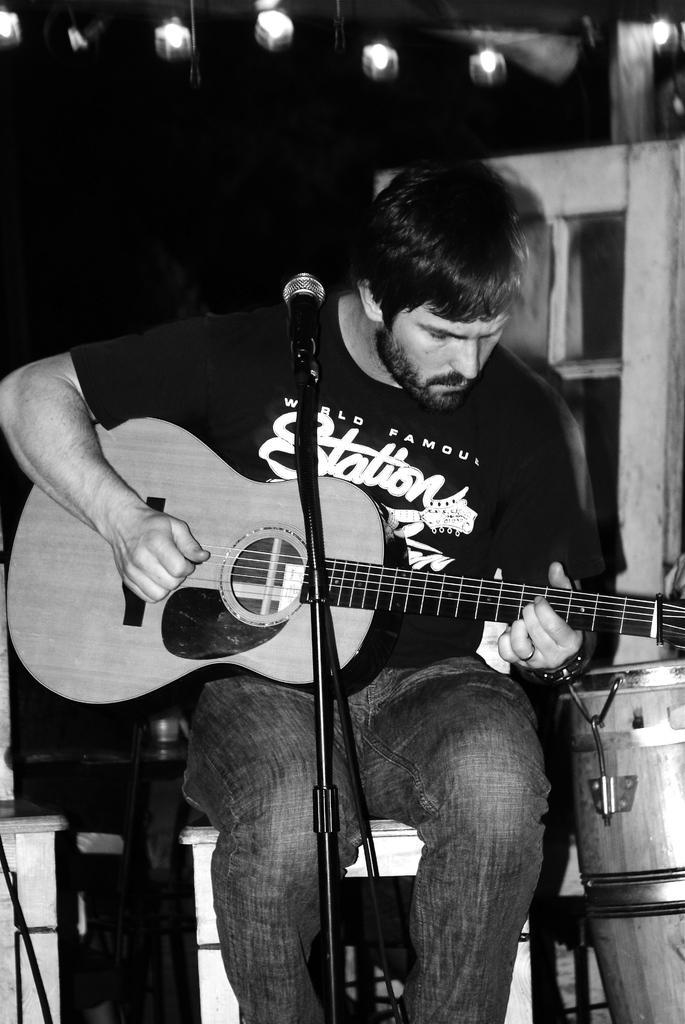Describe this image in one or two sentences. The person wearing black shirt is sitting on a stool and playing guitar in front of a mic. 